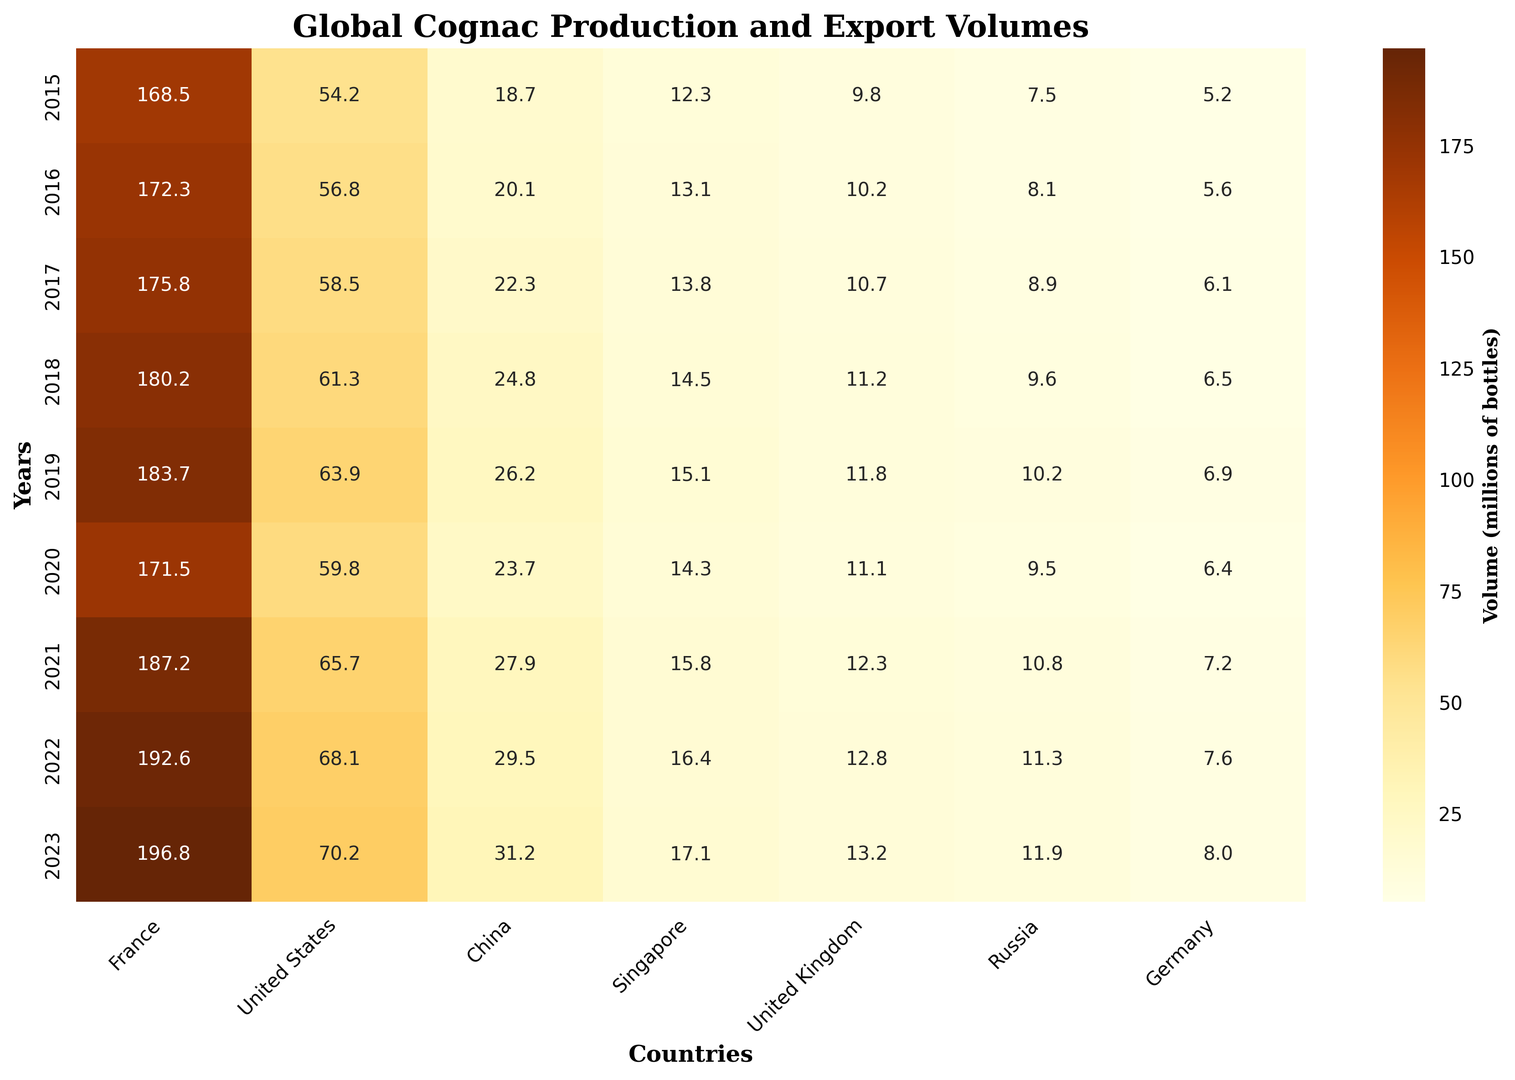What region had the highest cognac export volume in 2023? Look at the 2023 row and identify the region with the darkest shade. France has the highest value with 196.8.
Answer: France Which year had the lowest cognac export volume for the United Kingdom? Check each year's value for the United Kingdom and determine the lowest. The year 2015 has the lowest value of 9.8.
Answer: 2015 What was the total export volume for China across all years? Sum the values for China across all years: 18.7 + 20.1 + 22.3 + 24.8 + 26.2 + 23.7 + 27.9 + 29.5 + 31.2 = 224.4
Answer: 224.4 How did the export volume for Russia change from 2019 to 2020? Compare the values for Russia in 2019 and 2020. The values are 10.2 in 2019 and 9.5 in 2020. The change is 10.2 - 9.5 = 0.7.
Answer: Decreased by 0.7 Which region had the most consistent growth in export volumes from 2015 to 2023? Look across all years for each region and identify the one with steadily increasing values. The United States shows consistent growth each year from 54.2 to 70.2.
Answer: United States What is the difference in cognac export volume between France and Germany in 2023? Subtract Germany's value from France's value in 2023: 196.8 - 8.0 = 188.8.
Answer: 188.8 Which year saw the largest increase in export volumes for China compared to the previous year? Calculate the yearly differences for China and determine the largest: 20.1 - 18.7 = 1.4, 22.3 - 20.1 = 2.2, 24.8 - 22.3 = 2.5, 26.2 - 24.8 = 1.4, 23.7 - 26.2 = -2.5, 27.9 - 23.7 = 4.2, 29.5 - 27.9 = 1.6, 31.2 - 29.5 = 1.7. The largest increase is 4.2 in 2021.
Answer: 2021 What is the average export volume for Germany over the years shown? Calculate the average of Germany's values: (5.2 + 5.6 + 6.1 + 6.5 + 6.9 + 6.4 + 7.2 + 7.6 + 8.0) / 9 = 6.17
Answer: 6.17 How does the volumetric export trend for Singapore compare to that of the United States? Compare the yearly values for Singapore and the United States and note trends. Both have increasing values, but the United States shows a more pronounced, consistent increase than Singapore.
Answer: US more consistent increase Which year had the highest total export volume across all regions combined? Sum the total export volumes for each year and determine the highest. Calculations: 276.2 (2015), 286.1 (2016), 297.8 (2017), 308.1 (2018), 317.8 (2019), 296.3 (2020), 336.9 (2021), 338.3 (2022), 343.8 (2023). The year 2023 has the highest total export volume.
Answer: 2023 